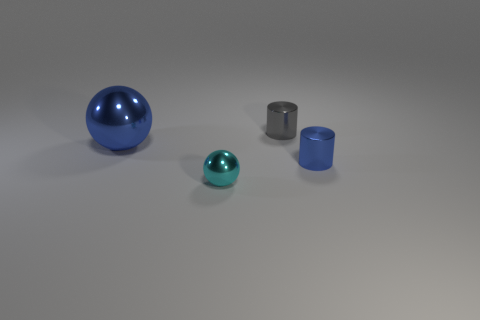Add 1 big brown cylinders. How many objects exist? 5 Subtract all tiny balls. Subtract all metallic cylinders. How many objects are left? 1 Add 2 tiny objects. How many tiny objects are left? 5 Add 3 small shiny cylinders. How many small shiny cylinders exist? 5 Subtract 0 green cubes. How many objects are left? 4 